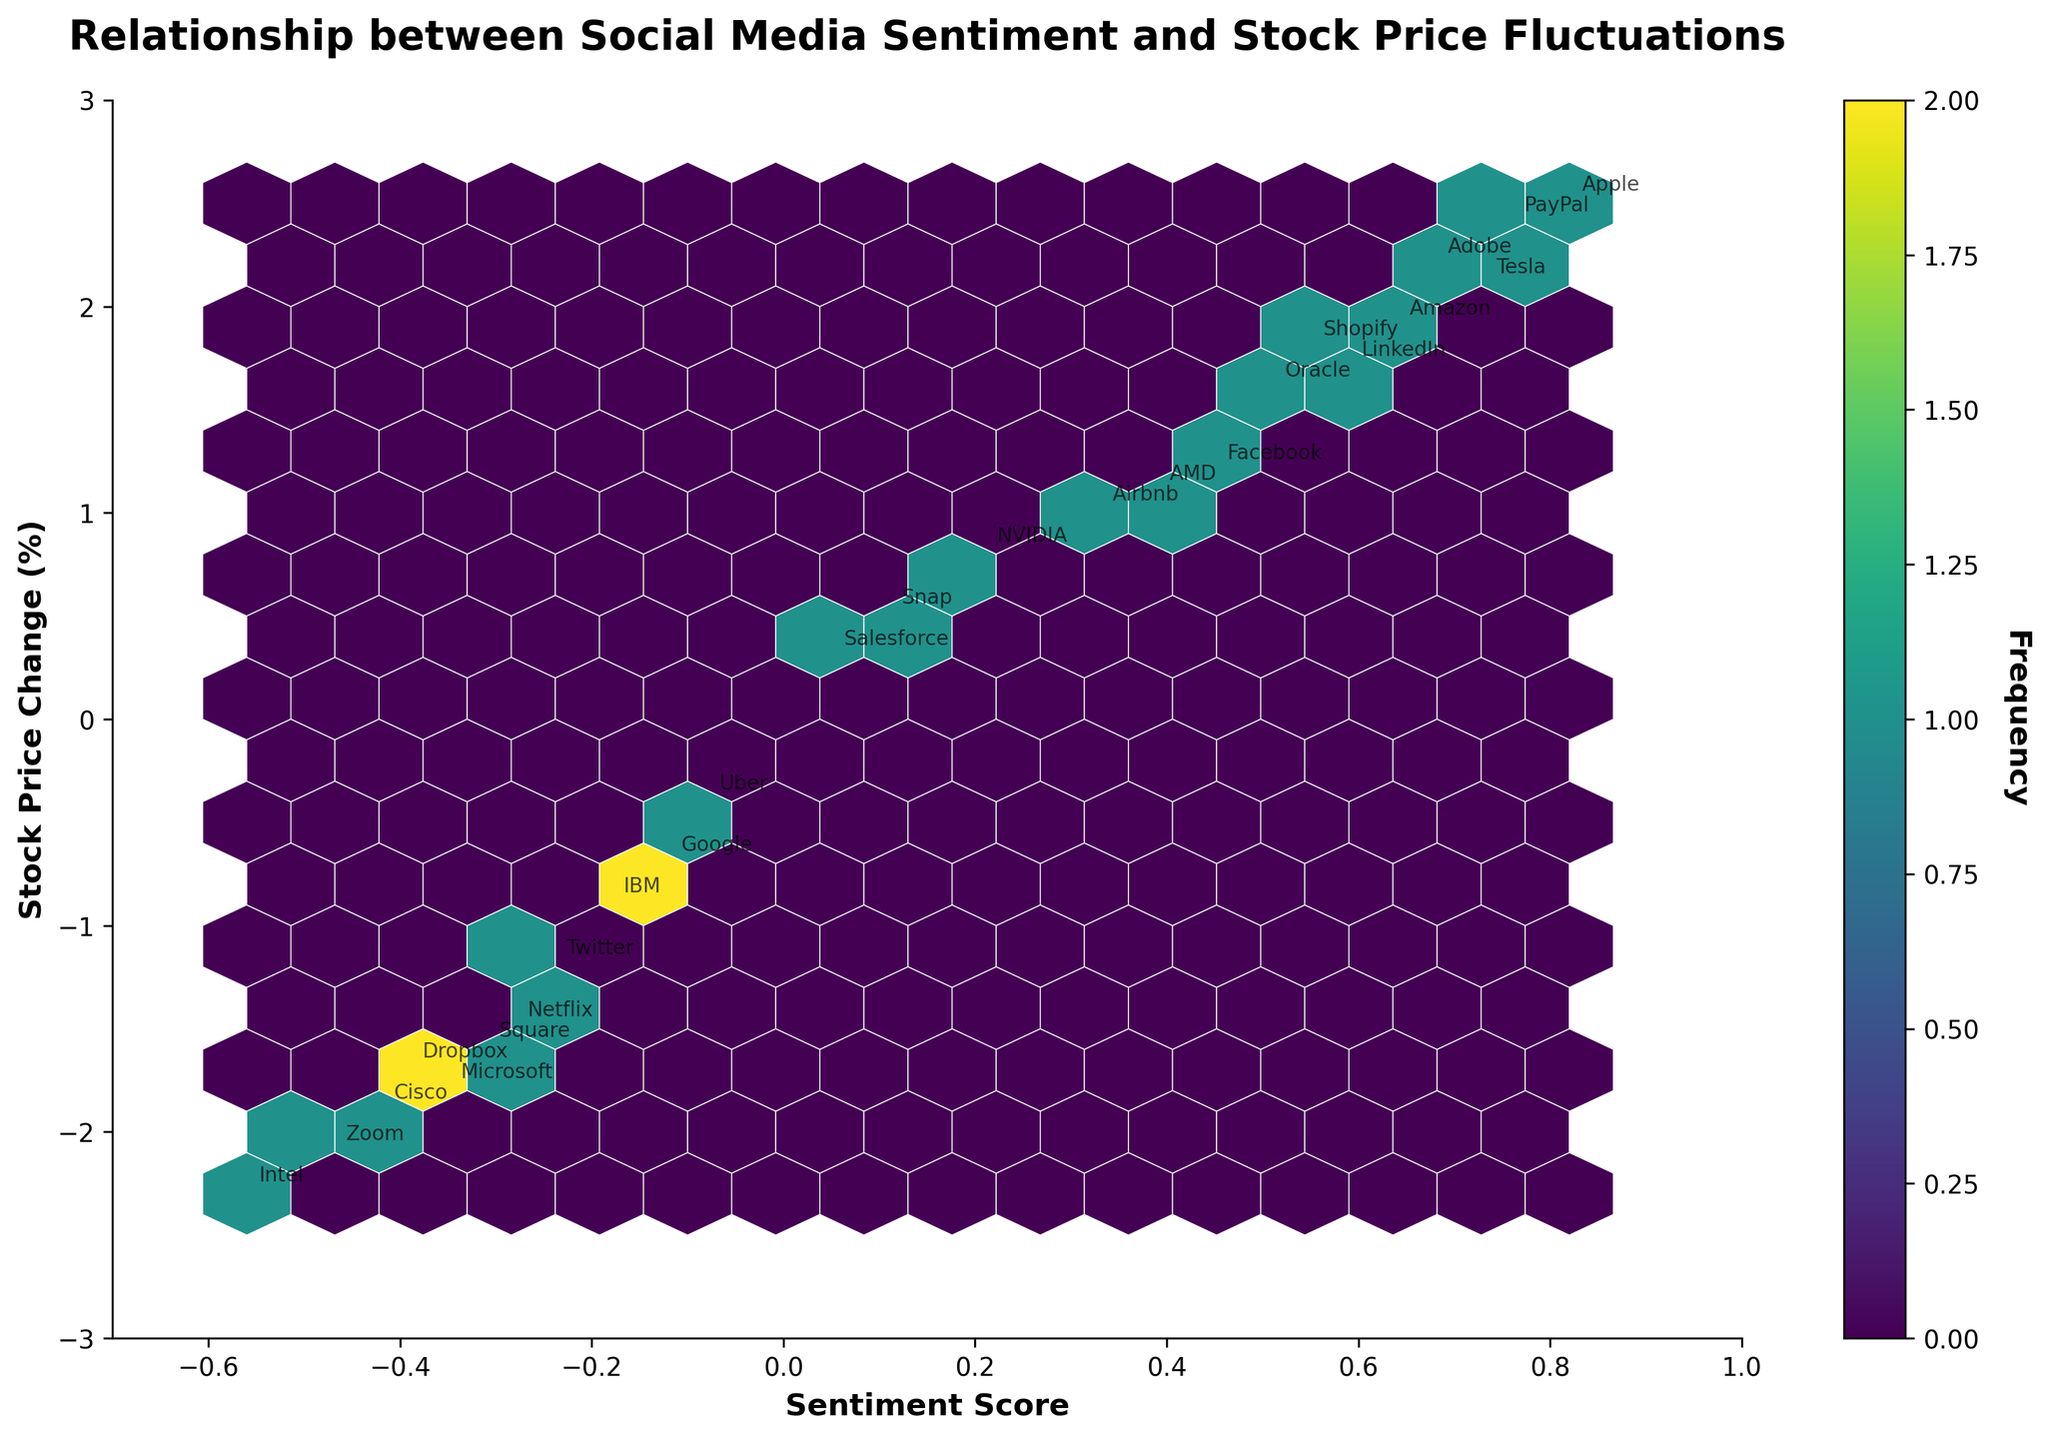What is the title of the plot? The title is bold and located at the top of the figure. It is meant to describe what the figure is about.
Answer: Relationship between Social Media Sentiment and Stock Price Fluctuations What do the axes represent in the plot? Look at the text along the x-axis and y-axis to see what dimensions they represent.
Answer: The x-axis represents Sentiment Score and the y-axis represents Stock Price Change (%) Which company has the highest positive sentiment score? Look at the annotations around the highest values on the x-axis.
Answer: Apple How many companies show positive sentiment and positive stock price change? Count the number of data points in the hexagonal bins where both sentiment score and stock price change are positive.
Answer: 11 Which companies have a negative sentiment score and a positive stock price change? Look for annotated data points that lie in the left part of the plot (negative sentiment score) but above the x-axis (positive stock price change).
Answer: None What does the color represent in the plot? Refer to the color bar that is usually positioned alongside the hexbin plot.
Answer: Frequency Which sentiment score range has the highest frequency of data points? Identify the color that is the most saturated/highest on the color bar and see which sentiment score ranges it corresponds to on the plot.
Answer: Between 0.2 and 0.6 By how much does Netflix's stock price change, and is it positive or negative? Locate the annotation for Netflix, and note the stock price change value and its sign.
Answer: -1.5, Negative Compare the sentiment score of Tesla and Uber. Which one is higher? Locate the annotations for Tesla and Uber and compare their sentiment scores.
Answer: Tesla has a higher sentiment score than Uber What are the stock price change ranges for companies with sentiment scores greater than 0.5? Look at the annotated data points with sentiment scores greater than 0.5 and note the range of stock price changes.
Answer: Stock price changes range from 1.6 to 2.5 (%) 